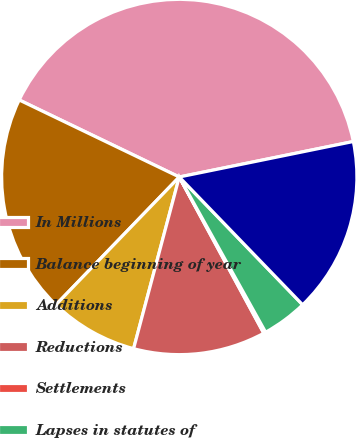<chart> <loc_0><loc_0><loc_500><loc_500><pie_chart><fcel>In Millions<fcel>Balance beginning of year<fcel>Additions<fcel>Reductions<fcel>Settlements<fcel>Lapses in statutes of<fcel>Balance end of year<nl><fcel>39.66%<fcel>19.92%<fcel>8.08%<fcel>12.03%<fcel>0.19%<fcel>4.14%<fcel>15.98%<nl></chart> 